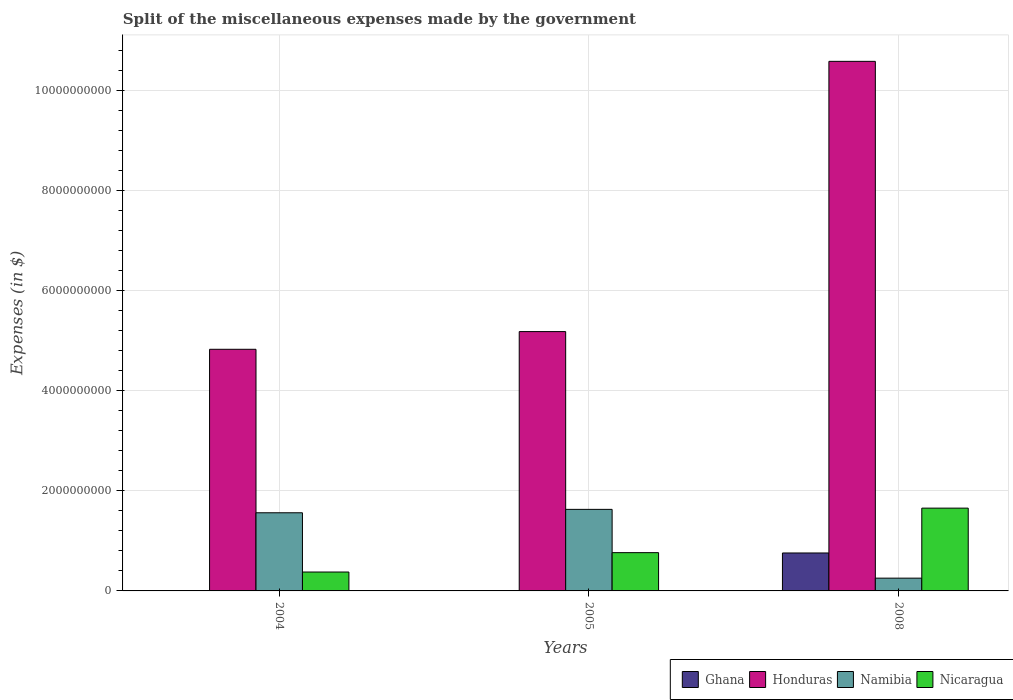How many groups of bars are there?
Keep it short and to the point. 3. Are the number of bars per tick equal to the number of legend labels?
Your answer should be compact. Yes. Are the number of bars on each tick of the X-axis equal?
Offer a very short reply. Yes. How many bars are there on the 3rd tick from the left?
Your response must be concise. 4. How many bars are there on the 2nd tick from the right?
Give a very brief answer. 4. What is the label of the 3rd group of bars from the left?
Ensure brevity in your answer.  2008. What is the miscellaneous expenses made by the government in Honduras in 2004?
Make the answer very short. 4.83e+09. Across all years, what is the maximum miscellaneous expenses made by the government in Namibia?
Provide a succinct answer. 1.63e+09. Across all years, what is the minimum miscellaneous expenses made by the government in Nicaragua?
Your response must be concise. 3.78e+08. In which year was the miscellaneous expenses made by the government in Nicaragua minimum?
Your answer should be compact. 2004. What is the total miscellaneous expenses made by the government in Ghana in the graph?
Your answer should be compact. 7.64e+08. What is the difference between the miscellaneous expenses made by the government in Honduras in 2004 and that in 2005?
Your response must be concise. -3.54e+08. What is the difference between the miscellaneous expenses made by the government in Ghana in 2008 and the miscellaneous expenses made by the government in Namibia in 2005?
Your answer should be very brief. -8.72e+08. What is the average miscellaneous expenses made by the government in Ghana per year?
Your answer should be compact. 2.55e+08. In the year 2004, what is the difference between the miscellaneous expenses made by the government in Honduras and miscellaneous expenses made by the government in Ghana?
Your answer should be compact. 4.83e+09. In how many years, is the miscellaneous expenses made by the government in Ghana greater than 400000000 $?
Make the answer very short. 1. What is the ratio of the miscellaneous expenses made by the government in Namibia in 2004 to that in 2008?
Give a very brief answer. 6.12. Is the miscellaneous expenses made by the government in Namibia in 2005 less than that in 2008?
Keep it short and to the point. No. Is the difference between the miscellaneous expenses made by the government in Honduras in 2004 and 2005 greater than the difference between the miscellaneous expenses made by the government in Ghana in 2004 and 2005?
Your response must be concise. No. What is the difference between the highest and the second highest miscellaneous expenses made by the government in Honduras?
Give a very brief answer. 5.40e+09. What is the difference between the highest and the lowest miscellaneous expenses made by the government in Nicaragua?
Ensure brevity in your answer.  1.28e+09. In how many years, is the miscellaneous expenses made by the government in Namibia greater than the average miscellaneous expenses made by the government in Namibia taken over all years?
Your answer should be compact. 2. Is the sum of the miscellaneous expenses made by the government in Ghana in 2004 and 2005 greater than the maximum miscellaneous expenses made by the government in Honduras across all years?
Your answer should be compact. No. Is it the case that in every year, the sum of the miscellaneous expenses made by the government in Namibia and miscellaneous expenses made by the government in Ghana is greater than the sum of miscellaneous expenses made by the government in Honduras and miscellaneous expenses made by the government in Nicaragua?
Make the answer very short. Yes. What does the 4th bar from the left in 2005 represents?
Make the answer very short. Nicaragua. What does the 3rd bar from the right in 2008 represents?
Ensure brevity in your answer.  Honduras. What is the difference between two consecutive major ticks on the Y-axis?
Ensure brevity in your answer.  2.00e+09. Does the graph contain any zero values?
Ensure brevity in your answer.  No. Where does the legend appear in the graph?
Give a very brief answer. Bottom right. What is the title of the graph?
Your answer should be compact. Split of the miscellaneous expenses made by the government. What is the label or title of the X-axis?
Ensure brevity in your answer.  Years. What is the label or title of the Y-axis?
Make the answer very short. Expenses (in $). What is the Expenses (in $) in Ghana in 2004?
Offer a very short reply. 1.21e+06. What is the Expenses (in $) of Honduras in 2004?
Give a very brief answer. 4.83e+09. What is the Expenses (in $) in Namibia in 2004?
Keep it short and to the point. 1.56e+09. What is the Expenses (in $) of Nicaragua in 2004?
Ensure brevity in your answer.  3.78e+08. What is the Expenses (in $) in Ghana in 2005?
Your response must be concise. 4.55e+06. What is the Expenses (in $) of Honduras in 2005?
Your response must be concise. 5.18e+09. What is the Expenses (in $) of Namibia in 2005?
Provide a succinct answer. 1.63e+09. What is the Expenses (in $) of Nicaragua in 2005?
Offer a very short reply. 7.65e+08. What is the Expenses (in $) of Ghana in 2008?
Your answer should be compact. 7.59e+08. What is the Expenses (in $) of Honduras in 2008?
Keep it short and to the point. 1.06e+1. What is the Expenses (in $) in Namibia in 2008?
Give a very brief answer. 2.55e+08. What is the Expenses (in $) of Nicaragua in 2008?
Your answer should be very brief. 1.65e+09. Across all years, what is the maximum Expenses (in $) of Ghana?
Make the answer very short. 7.59e+08. Across all years, what is the maximum Expenses (in $) of Honduras?
Offer a terse response. 1.06e+1. Across all years, what is the maximum Expenses (in $) of Namibia?
Keep it short and to the point. 1.63e+09. Across all years, what is the maximum Expenses (in $) in Nicaragua?
Make the answer very short. 1.65e+09. Across all years, what is the minimum Expenses (in $) of Ghana?
Provide a short and direct response. 1.21e+06. Across all years, what is the minimum Expenses (in $) of Honduras?
Provide a short and direct response. 4.83e+09. Across all years, what is the minimum Expenses (in $) in Namibia?
Your answer should be very brief. 2.55e+08. Across all years, what is the minimum Expenses (in $) of Nicaragua?
Offer a very short reply. 3.78e+08. What is the total Expenses (in $) in Ghana in the graph?
Make the answer very short. 7.64e+08. What is the total Expenses (in $) of Honduras in the graph?
Keep it short and to the point. 2.06e+1. What is the total Expenses (in $) of Namibia in the graph?
Give a very brief answer. 3.45e+09. What is the total Expenses (in $) of Nicaragua in the graph?
Your answer should be compact. 2.80e+09. What is the difference between the Expenses (in $) of Ghana in 2004 and that in 2005?
Keep it short and to the point. -3.34e+06. What is the difference between the Expenses (in $) in Honduras in 2004 and that in 2005?
Ensure brevity in your answer.  -3.54e+08. What is the difference between the Expenses (in $) of Namibia in 2004 and that in 2005?
Give a very brief answer. -6.80e+07. What is the difference between the Expenses (in $) of Nicaragua in 2004 and that in 2005?
Offer a very short reply. -3.87e+08. What is the difference between the Expenses (in $) of Ghana in 2004 and that in 2008?
Make the answer very short. -7.57e+08. What is the difference between the Expenses (in $) in Honduras in 2004 and that in 2008?
Your answer should be very brief. -5.76e+09. What is the difference between the Expenses (in $) in Namibia in 2004 and that in 2008?
Your answer should be very brief. 1.31e+09. What is the difference between the Expenses (in $) of Nicaragua in 2004 and that in 2008?
Your answer should be very brief. -1.28e+09. What is the difference between the Expenses (in $) of Ghana in 2005 and that in 2008?
Offer a terse response. -7.54e+08. What is the difference between the Expenses (in $) in Honduras in 2005 and that in 2008?
Give a very brief answer. -5.40e+09. What is the difference between the Expenses (in $) in Namibia in 2005 and that in 2008?
Give a very brief answer. 1.37e+09. What is the difference between the Expenses (in $) in Nicaragua in 2005 and that in 2008?
Offer a very short reply. -8.90e+08. What is the difference between the Expenses (in $) of Ghana in 2004 and the Expenses (in $) of Honduras in 2005?
Make the answer very short. -5.18e+09. What is the difference between the Expenses (in $) of Ghana in 2004 and the Expenses (in $) of Namibia in 2005?
Provide a succinct answer. -1.63e+09. What is the difference between the Expenses (in $) in Ghana in 2004 and the Expenses (in $) in Nicaragua in 2005?
Provide a succinct answer. -7.64e+08. What is the difference between the Expenses (in $) of Honduras in 2004 and the Expenses (in $) of Namibia in 2005?
Your answer should be very brief. 3.20e+09. What is the difference between the Expenses (in $) of Honduras in 2004 and the Expenses (in $) of Nicaragua in 2005?
Your answer should be compact. 4.07e+09. What is the difference between the Expenses (in $) of Namibia in 2004 and the Expenses (in $) of Nicaragua in 2005?
Provide a succinct answer. 7.97e+08. What is the difference between the Expenses (in $) of Ghana in 2004 and the Expenses (in $) of Honduras in 2008?
Offer a terse response. -1.06e+1. What is the difference between the Expenses (in $) in Ghana in 2004 and the Expenses (in $) in Namibia in 2008?
Ensure brevity in your answer.  -2.54e+08. What is the difference between the Expenses (in $) of Ghana in 2004 and the Expenses (in $) of Nicaragua in 2008?
Offer a terse response. -1.65e+09. What is the difference between the Expenses (in $) of Honduras in 2004 and the Expenses (in $) of Namibia in 2008?
Provide a short and direct response. 4.57e+09. What is the difference between the Expenses (in $) of Honduras in 2004 and the Expenses (in $) of Nicaragua in 2008?
Provide a short and direct response. 3.18e+09. What is the difference between the Expenses (in $) of Namibia in 2004 and the Expenses (in $) of Nicaragua in 2008?
Provide a short and direct response. -9.26e+07. What is the difference between the Expenses (in $) in Ghana in 2005 and the Expenses (in $) in Honduras in 2008?
Your answer should be very brief. -1.06e+1. What is the difference between the Expenses (in $) in Ghana in 2005 and the Expenses (in $) in Namibia in 2008?
Offer a terse response. -2.51e+08. What is the difference between the Expenses (in $) of Ghana in 2005 and the Expenses (in $) of Nicaragua in 2008?
Your response must be concise. -1.65e+09. What is the difference between the Expenses (in $) of Honduras in 2005 and the Expenses (in $) of Namibia in 2008?
Your answer should be very brief. 4.93e+09. What is the difference between the Expenses (in $) in Honduras in 2005 and the Expenses (in $) in Nicaragua in 2008?
Your answer should be very brief. 3.53e+09. What is the difference between the Expenses (in $) in Namibia in 2005 and the Expenses (in $) in Nicaragua in 2008?
Ensure brevity in your answer.  -2.46e+07. What is the average Expenses (in $) of Ghana per year?
Offer a terse response. 2.55e+08. What is the average Expenses (in $) in Honduras per year?
Ensure brevity in your answer.  6.87e+09. What is the average Expenses (in $) in Namibia per year?
Offer a terse response. 1.15e+09. What is the average Expenses (in $) of Nicaragua per year?
Your answer should be very brief. 9.33e+08. In the year 2004, what is the difference between the Expenses (in $) of Ghana and Expenses (in $) of Honduras?
Offer a terse response. -4.83e+09. In the year 2004, what is the difference between the Expenses (in $) of Ghana and Expenses (in $) of Namibia?
Offer a terse response. -1.56e+09. In the year 2004, what is the difference between the Expenses (in $) of Ghana and Expenses (in $) of Nicaragua?
Provide a succinct answer. -3.77e+08. In the year 2004, what is the difference between the Expenses (in $) in Honduras and Expenses (in $) in Namibia?
Offer a terse response. 3.27e+09. In the year 2004, what is the difference between the Expenses (in $) in Honduras and Expenses (in $) in Nicaragua?
Make the answer very short. 4.45e+09. In the year 2004, what is the difference between the Expenses (in $) of Namibia and Expenses (in $) of Nicaragua?
Your answer should be compact. 1.18e+09. In the year 2005, what is the difference between the Expenses (in $) of Ghana and Expenses (in $) of Honduras?
Offer a terse response. -5.18e+09. In the year 2005, what is the difference between the Expenses (in $) of Ghana and Expenses (in $) of Namibia?
Ensure brevity in your answer.  -1.63e+09. In the year 2005, what is the difference between the Expenses (in $) of Ghana and Expenses (in $) of Nicaragua?
Offer a very short reply. -7.60e+08. In the year 2005, what is the difference between the Expenses (in $) in Honduras and Expenses (in $) in Namibia?
Provide a succinct answer. 3.55e+09. In the year 2005, what is the difference between the Expenses (in $) of Honduras and Expenses (in $) of Nicaragua?
Your answer should be very brief. 4.42e+09. In the year 2005, what is the difference between the Expenses (in $) of Namibia and Expenses (in $) of Nicaragua?
Make the answer very short. 8.65e+08. In the year 2008, what is the difference between the Expenses (in $) in Ghana and Expenses (in $) in Honduras?
Provide a succinct answer. -9.83e+09. In the year 2008, what is the difference between the Expenses (in $) of Ghana and Expenses (in $) of Namibia?
Provide a short and direct response. 5.03e+08. In the year 2008, what is the difference between the Expenses (in $) of Ghana and Expenses (in $) of Nicaragua?
Provide a short and direct response. -8.96e+08. In the year 2008, what is the difference between the Expenses (in $) in Honduras and Expenses (in $) in Namibia?
Provide a succinct answer. 1.03e+1. In the year 2008, what is the difference between the Expenses (in $) in Honduras and Expenses (in $) in Nicaragua?
Keep it short and to the point. 8.93e+09. In the year 2008, what is the difference between the Expenses (in $) in Namibia and Expenses (in $) in Nicaragua?
Ensure brevity in your answer.  -1.40e+09. What is the ratio of the Expenses (in $) in Ghana in 2004 to that in 2005?
Your response must be concise. 0.27. What is the ratio of the Expenses (in $) of Honduras in 2004 to that in 2005?
Ensure brevity in your answer.  0.93. What is the ratio of the Expenses (in $) in Nicaragua in 2004 to that in 2005?
Your answer should be very brief. 0.49. What is the ratio of the Expenses (in $) of Ghana in 2004 to that in 2008?
Offer a terse response. 0. What is the ratio of the Expenses (in $) of Honduras in 2004 to that in 2008?
Your answer should be compact. 0.46. What is the ratio of the Expenses (in $) of Namibia in 2004 to that in 2008?
Give a very brief answer. 6.12. What is the ratio of the Expenses (in $) of Nicaragua in 2004 to that in 2008?
Keep it short and to the point. 0.23. What is the ratio of the Expenses (in $) in Ghana in 2005 to that in 2008?
Your answer should be compact. 0.01. What is the ratio of the Expenses (in $) of Honduras in 2005 to that in 2008?
Your answer should be very brief. 0.49. What is the ratio of the Expenses (in $) of Namibia in 2005 to that in 2008?
Your answer should be compact. 6.38. What is the ratio of the Expenses (in $) in Nicaragua in 2005 to that in 2008?
Offer a terse response. 0.46. What is the difference between the highest and the second highest Expenses (in $) of Ghana?
Provide a short and direct response. 7.54e+08. What is the difference between the highest and the second highest Expenses (in $) of Honduras?
Offer a very short reply. 5.40e+09. What is the difference between the highest and the second highest Expenses (in $) of Namibia?
Your answer should be compact. 6.80e+07. What is the difference between the highest and the second highest Expenses (in $) of Nicaragua?
Give a very brief answer. 8.90e+08. What is the difference between the highest and the lowest Expenses (in $) of Ghana?
Provide a succinct answer. 7.57e+08. What is the difference between the highest and the lowest Expenses (in $) of Honduras?
Keep it short and to the point. 5.76e+09. What is the difference between the highest and the lowest Expenses (in $) of Namibia?
Give a very brief answer. 1.37e+09. What is the difference between the highest and the lowest Expenses (in $) in Nicaragua?
Give a very brief answer. 1.28e+09. 